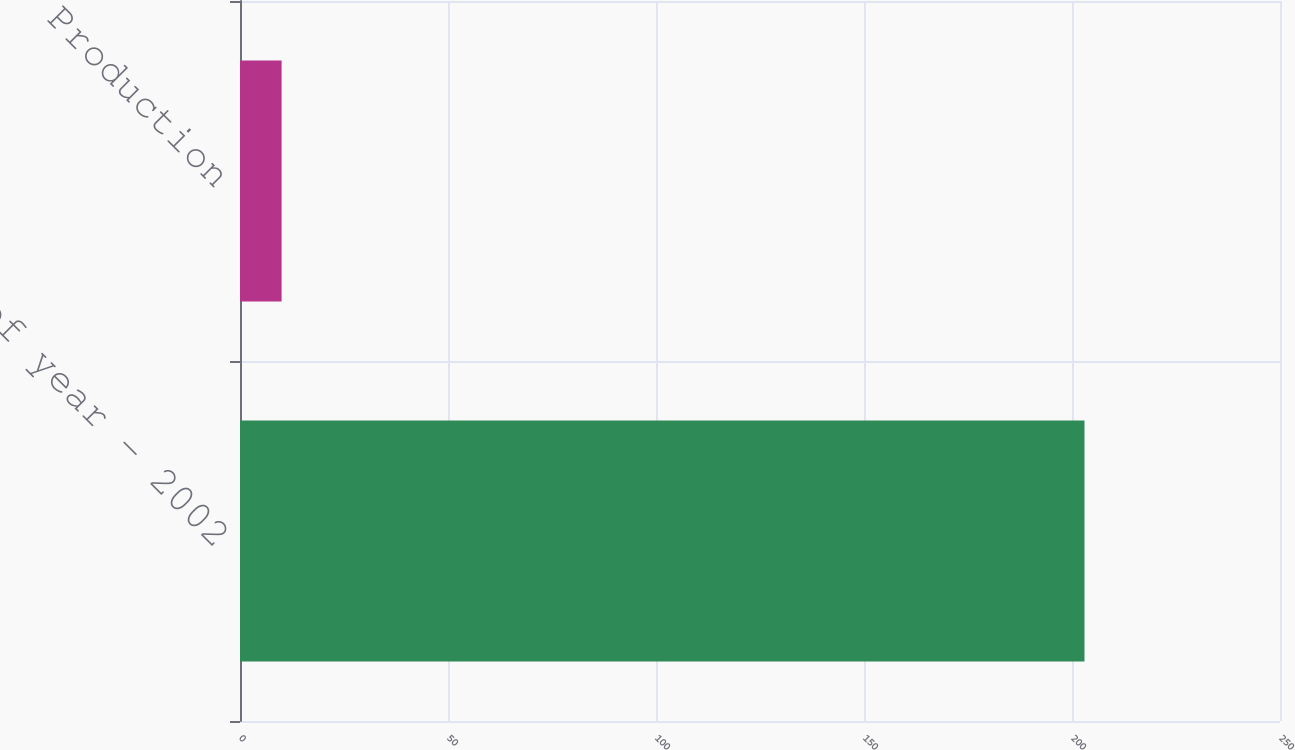<chart> <loc_0><loc_0><loc_500><loc_500><bar_chart><fcel>End of year - 2002<fcel>Production<nl><fcel>203<fcel>10<nl></chart> 